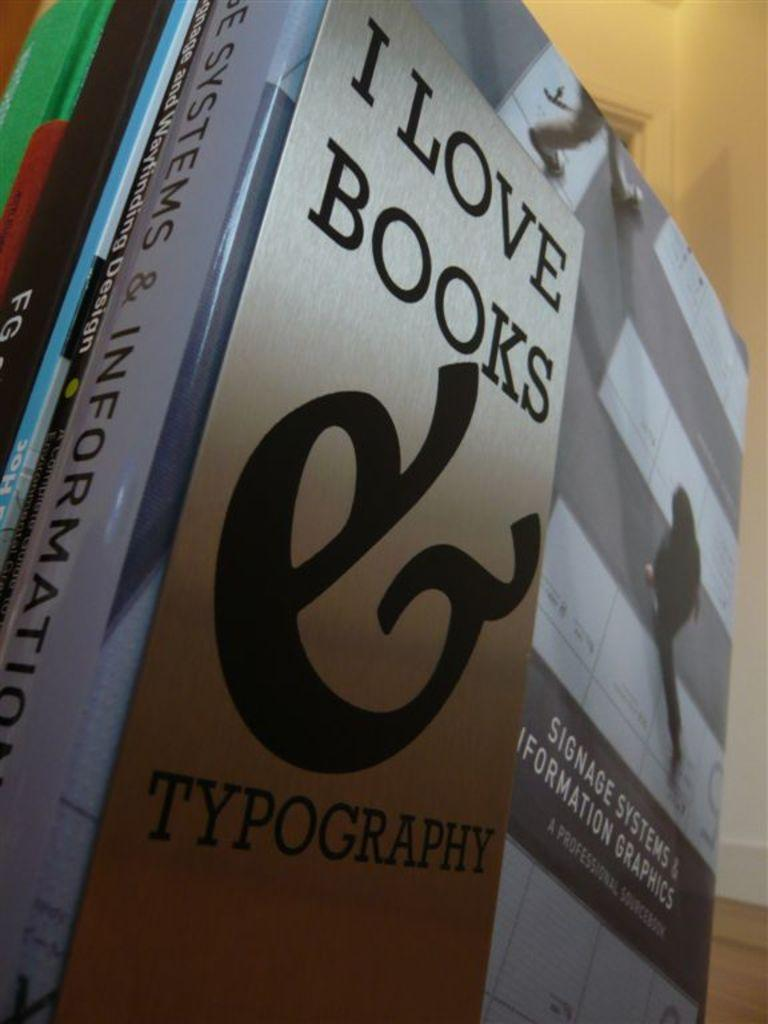<image>
Render a clear and concise summary of the photo. Several books standing up one has a title that says I love books 